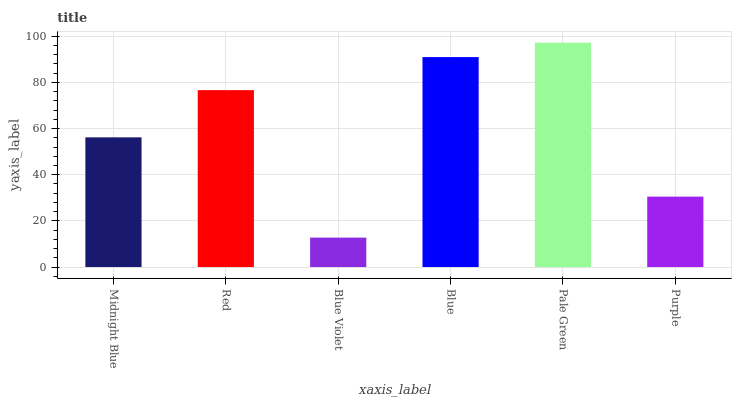Is Blue Violet the minimum?
Answer yes or no. Yes. Is Pale Green the maximum?
Answer yes or no. Yes. Is Red the minimum?
Answer yes or no. No. Is Red the maximum?
Answer yes or no. No. Is Red greater than Midnight Blue?
Answer yes or no. Yes. Is Midnight Blue less than Red?
Answer yes or no. Yes. Is Midnight Blue greater than Red?
Answer yes or no. No. Is Red less than Midnight Blue?
Answer yes or no. No. Is Red the high median?
Answer yes or no. Yes. Is Midnight Blue the low median?
Answer yes or no. Yes. Is Purple the high median?
Answer yes or no. No. Is Pale Green the low median?
Answer yes or no. No. 